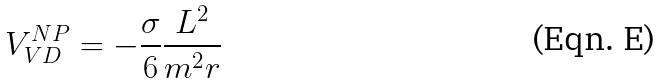<formula> <loc_0><loc_0><loc_500><loc_500>V _ { V D } ^ { N P } = - { \frac { \sigma } { 6 } } { \frac { L ^ { 2 } } { m ^ { 2 } r } }</formula> 